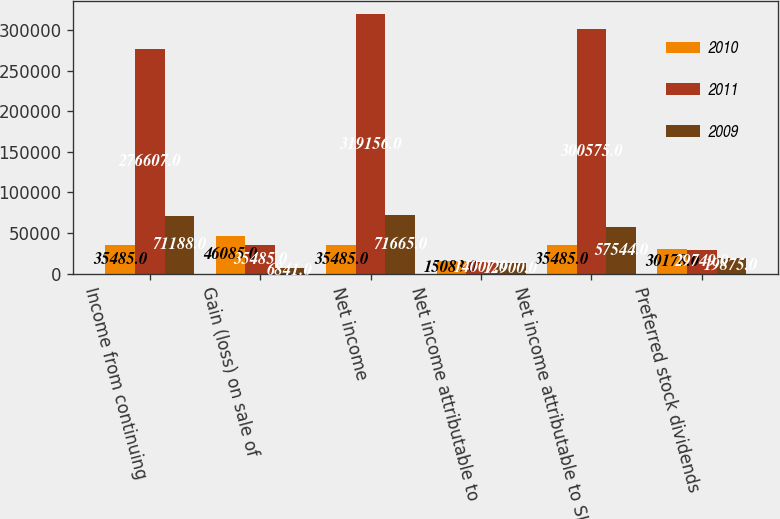<chart> <loc_0><loc_0><loc_500><loc_500><stacked_bar_chart><ecel><fcel>Income from continuing<fcel>Gain (loss) on sale of<fcel>Net income<fcel>Net income attributable to<fcel>Net income attributable to SL<fcel>Preferred stock dividends<nl><fcel>2010<fcel>35485<fcel>46085<fcel>35485<fcel>15083<fcel>35485<fcel>30178<nl><fcel>2011<fcel>276607<fcel>35485<fcel>319156<fcel>14007<fcel>300575<fcel>29749<nl><fcel>2009<fcel>71188<fcel>6841<fcel>71665<fcel>12900<fcel>57544<fcel>19875<nl></chart> 